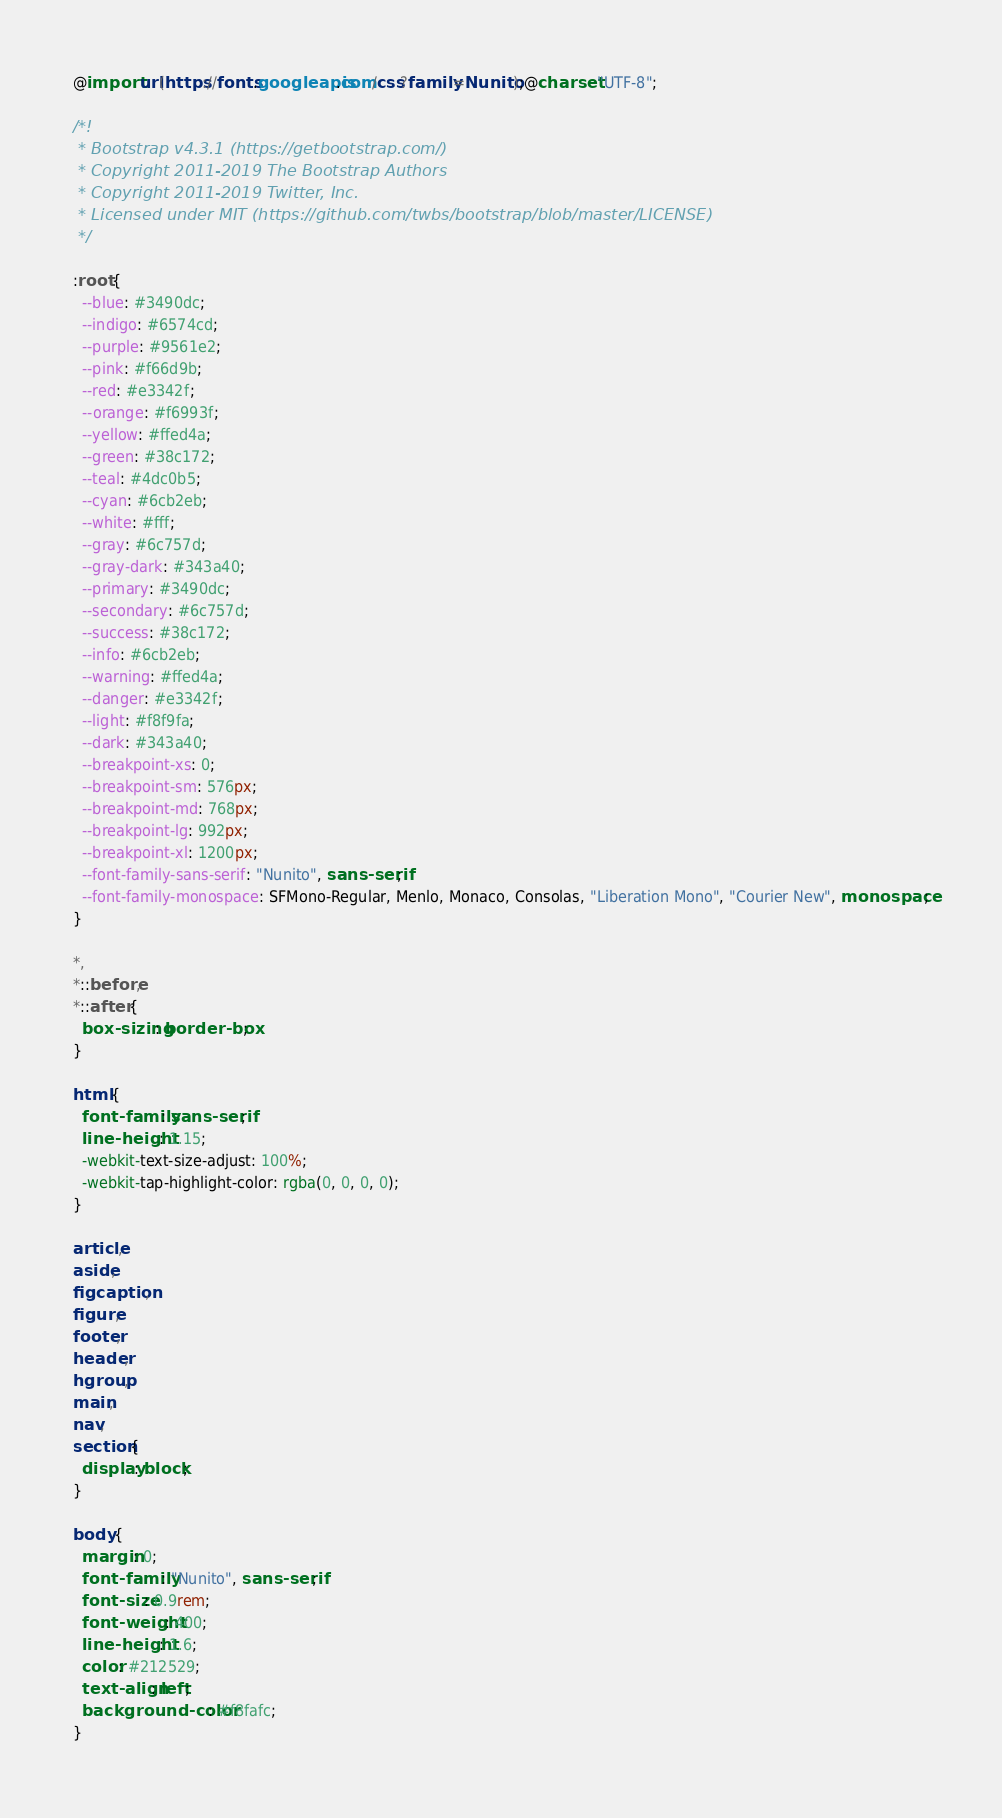Convert code to text. <code><loc_0><loc_0><loc_500><loc_500><_CSS_>@import url(https://fonts.googleapis.com/css?family=Nunito);@charset "UTF-8";

/*!
 * Bootstrap v4.3.1 (https://getbootstrap.com/)
 * Copyright 2011-2019 The Bootstrap Authors
 * Copyright 2011-2019 Twitter, Inc.
 * Licensed under MIT (https://github.com/twbs/bootstrap/blob/master/LICENSE)
 */

:root {
  --blue: #3490dc;
  --indigo: #6574cd;
  --purple: #9561e2;
  --pink: #f66d9b;
  --red: #e3342f;
  --orange: #f6993f;
  --yellow: #ffed4a;
  --green: #38c172;
  --teal: #4dc0b5;
  --cyan: #6cb2eb;
  --white: #fff;
  --gray: #6c757d;
  --gray-dark: #343a40;
  --primary: #3490dc;
  --secondary: #6c757d;
  --success: #38c172;
  --info: #6cb2eb;
  --warning: #ffed4a;
  --danger: #e3342f;
  --light: #f8f9fa;
  --dark: #343a40;
  --breakpoint-xs: 0;
  --breakpoint-sm: 576px;
  --breakpoint-md: 768px;
  --breakpoint-lg: 992px;
  --breakpoint-xl: 1200px;
  --font-family-sans-serif: "Nunito", sans-serif;
  --font-family-monospace: SFMono-Regular, Menlo, Monaco, Consolas, "Liberation Mono", "Courier New", monospace;
}

*,
*::before,
*::after {
  box-sizing: border-box;
}

html {
  font-family: sans-serif;
  line-height: 1.15;
  -webkit-text-size-adjust: 100%;
  -webkit-tap-highlight-color: rgba(0, 0, 0, 0);
}

article,
aside,
figcaption,
figure,
footer,
header,
hgroup,
main,
nav,
section {
  display: block;
}

body {
  margin: 0;
  font-family: "Nunito", sans-serif;
  font-size: 0.9rem;
  font-weight: 400;
  line-height: 1.6;
  color: #212529;
  text-align: left;
  background-color: #f8fafc;
}
</code> 